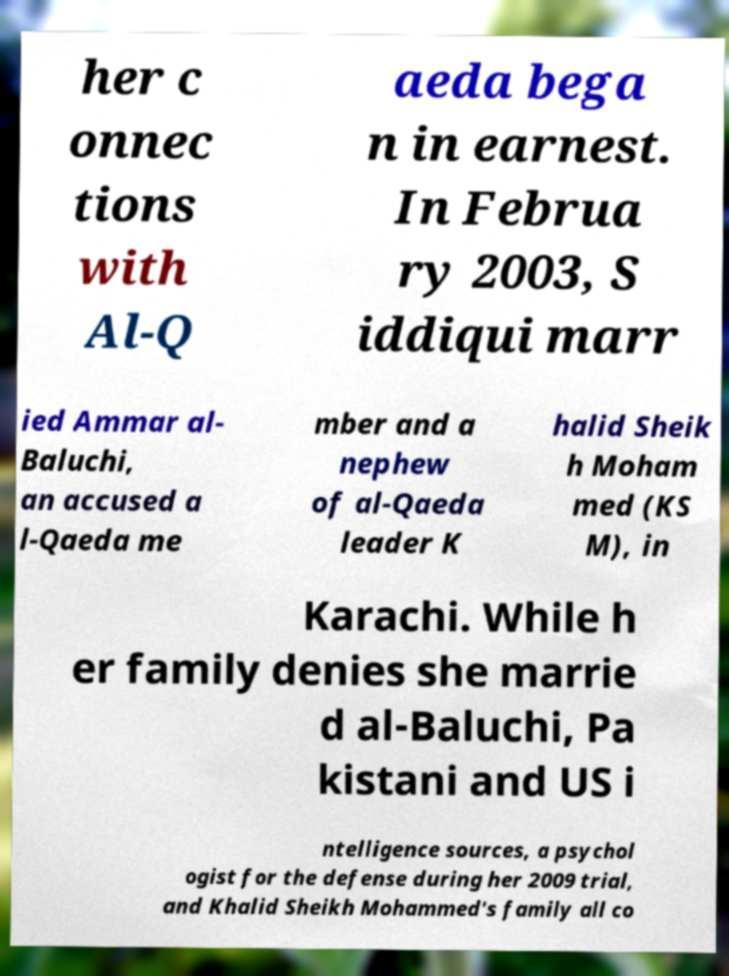I need the written content from this picture converted into text. Can you do that? her c onnec tions with Al-Q aeda bega n in earnest. In Februa ry 2003, S iddiqui marr ied Ammar al- Baluchi, an accused a l-Qaeda me mber and a nephew of al-Qaeda leader K halid Sheik h Moham med (KS M), in Karachi. While h er family denies she marrie d al-Baluchi, Pa kistani and US i ntelligence sources, a psychol ogist for the defense during her 2009 trial, and Khalid Sheikh Mohammed's family all co 